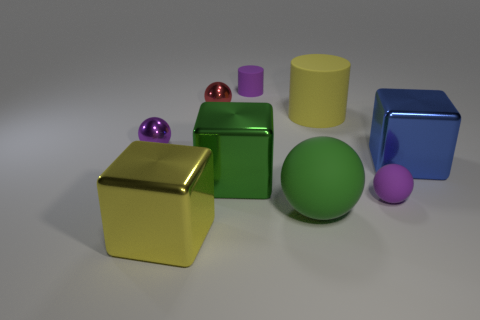How many small red balls are to the right of the small purple ball that is on the right side of the yellow metallic cube?
Your response must be concise. 0. How many metal things are both right of the small purple cylinder and left of the blue metal cube?
Provide a short and direct response. 0. What number of things are either red shiny things or tiny purple spheres that are in front of the tiny purple cylinder?
Offer a terse response. 3. What size is the green thing that is made of the same material as the small purple cylinder?
Provide a succinct answer. Large. What shape is the purple matte object that is behind the tiny purple matte thing that is in front of the big blue metallic cube?
Provide a short and direct response. Cylinder. How many gray things are tiny metallic balls or cylinders?
Offer a very short reply. 0. Are there any big balls that are in front of the tiny rubber cylinder to the right of the cube that is on the left side of the large green metal thing?
Ensure brevity in your answer.  Yes. There is a large thing that is the same color as the large cylinder; what is its shape?
Keep it short and to the point. Cube. Is there any other thing that is made of the same material as the big green cube?
Give a very brief answer. Yes. How many large objects are cyan cylinders or green objects?
Provide a short and direct response. 2. 